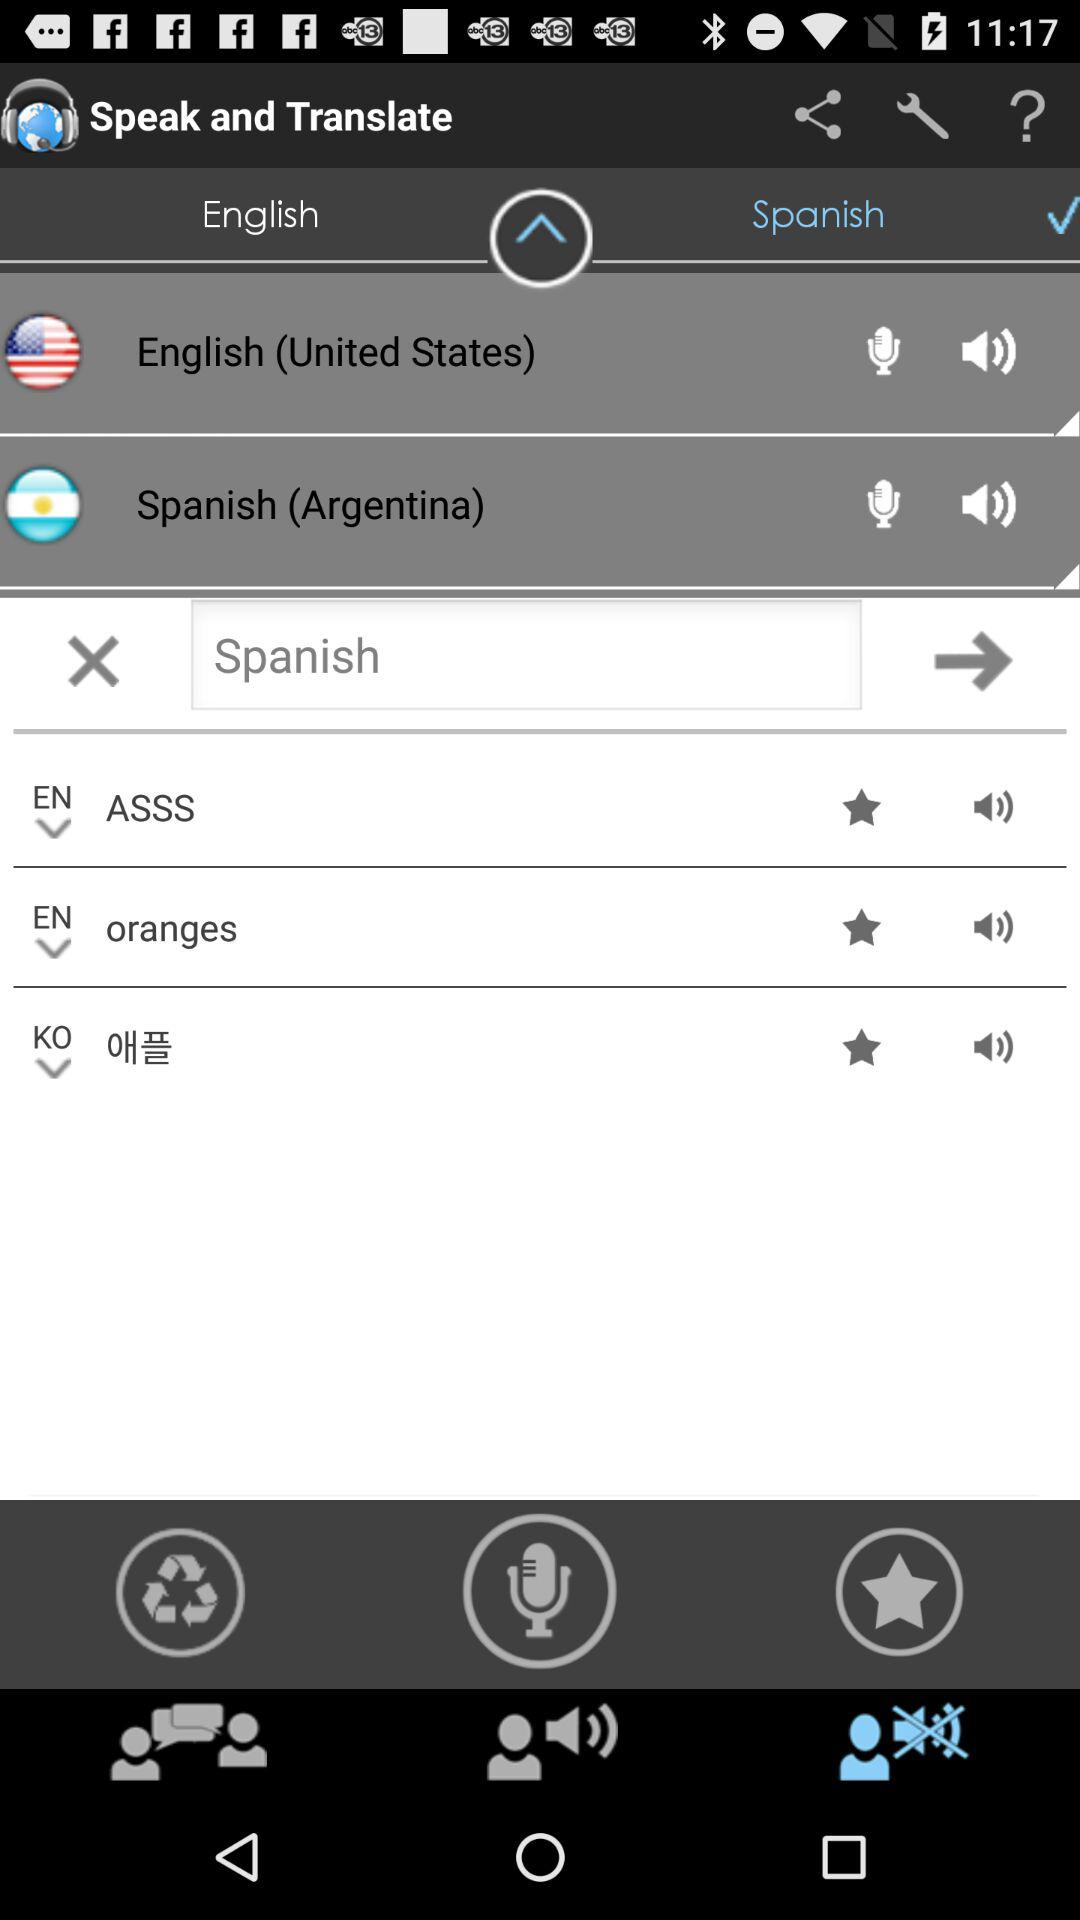In which language does the person want the translation? The person wants the translation in Spanish. 